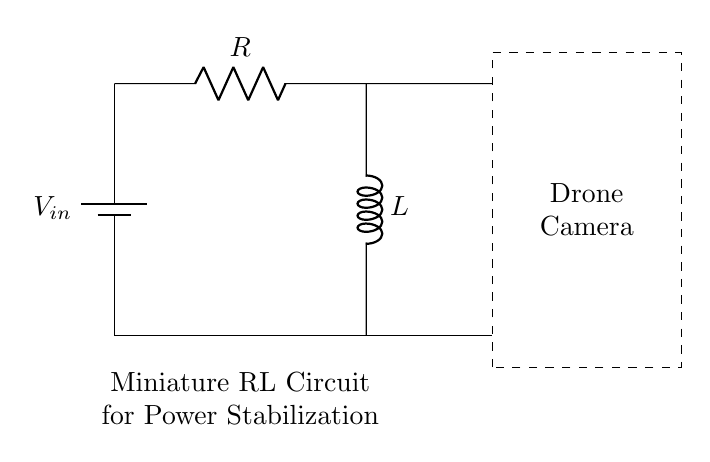What is the input voltage of this circuit? The input voltage is represented by V_in in the circuit diagram, which indicates the potential supplied to the circuit.
Answer: V_in What is the component that provides resistance? The component that provides resistance in the circuit is labeled as R, which is a standard resistor in electrical circuits.
Answer: R What is the value of the inductor in the circuit? The inductor is labeled as L, referring to the inductance in the circuit; however, the value is not specified in the diagram.
Answer: L How many components are there in this RL circuit? The circuit has three primary components: one resistor (R), one inductor (L), and one power supply (V_in), making a total of three.
Answer: 3 Why is an inductor used in this circuit? The inductor is used to stabilize the power output by resisting changes in current, which helps in smoothing out the voltage fluctuations, making it ideal for applications like drone-mounted cameras.
Answer: To stabilize power What happens when the switch is closed in this RL circuit? Closing the switch would allow current to flow from the battery through the resistor and inductor, causing the inductor to build up magnetic energy, which can stabilize the current flow to the drone camera during operation.
Answer: Current flows What is the purpose of the dashed rectangle in this circuit? The dashed rectangle highlights the section of the circuit dedicated for the drone camera, indicating that the power stabilization provided by the RL circuit directly supports the functioning of the camera.
Answer: Drone camera 